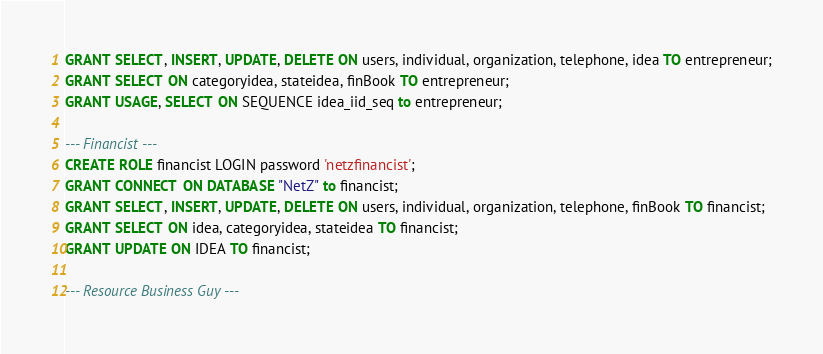<code> <loc_0><loc_0><loc_500><loc_500><_SQL_>GRANT SELECT, INSERT, UPDATE, DELETE ON users, individual, organization, telephone, idea TO entrepreneur;
GRANT SELECT ON categoryidea, stateidea, finBook TO entrepreneur;
GRANT USAGE, SELECT ON SEQUENCE idea_iid_seq to entrepreneur;

--- Financist ---
CREATE ROLE financist LOGIN password 'netzfinancist';
GRANT CONNECT ON DATABASE "NetZ" to financist;
GRANT SELECT, INSERT, UPDATE, DELETE ON users, individual, organization, telephone, finBook TO financist;
GRANT SELECT ON idea, categoryidea, stateidea TO financist;
GRANT UPDATE ON IDEA TO financist;

--- Resource Business Guy ---</code> 